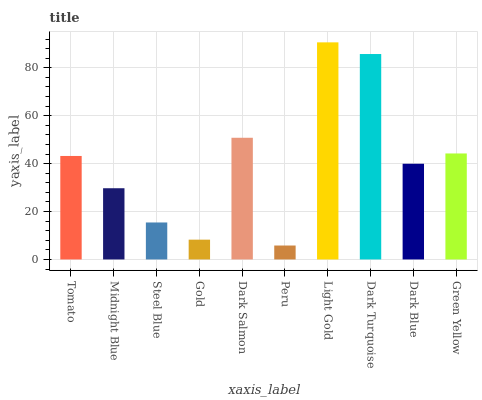Is Peru the minimum?
Answer yes or no. Yes. Is Light Gold the maximum?
Answer yes or no. Yes. Is Midnight Blue the minimum?
Answer yes or no. No. Is Midnight Blue the maximum?
Answer yes or no. No. Is Tomato greater than Midnight Blue?
Answer yes or no. Yes. Is Midnight Blue less than Tomato?
Answer yes or no. Yes. Is Midnight Blue greater than Tomato?
Answer yes or no. No. Is Tomato less than Midnight Blue?
Answer yes or no. No. Is Tomato the high median?
Answer yes or no. Yes. Is Dark Blue the low median?
Answer yes or no. Yes. Is Green Yellow the high median?
Answer yes or no. No. Is Midnight Blue the low median?
Answer yes or no. No. 